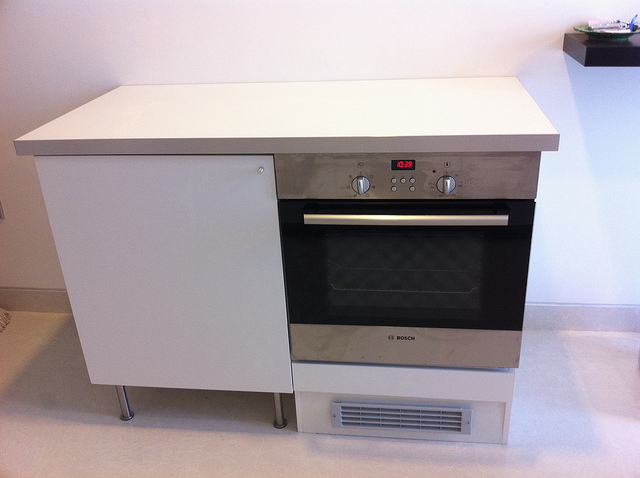Identify the text displayed in this image. 0:39 